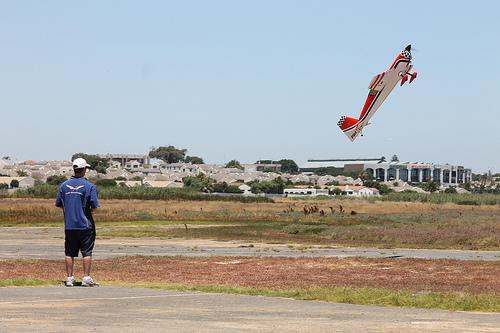Question: what is the man doing?
Choices:
A. Sleeping.
B. Eating.
C. Watching the plane.
D. Walking.
Answer with the letter. Answer: C Question: where is the plane?
Choices:
A. In the air.
B. At the terminal.
C. On the runway.
D. In the museum.
Answer with the letter. Answer: A Question: who is in the picture?
Choices:
A. A crowd.
B. A woman.
C. Kids.
D. A man.
Answer with the letter. Answer: D Question: what color is the man's shirt?
Choices:
A. Blue.
B. Red.
C. Green.
D. Tan.
Answer with the letter. Answer: A Question: how many planes?
Choices:
A. 5.
B. 1.
C. 6.
D. 3.
Answer with the letter. Answer: B 